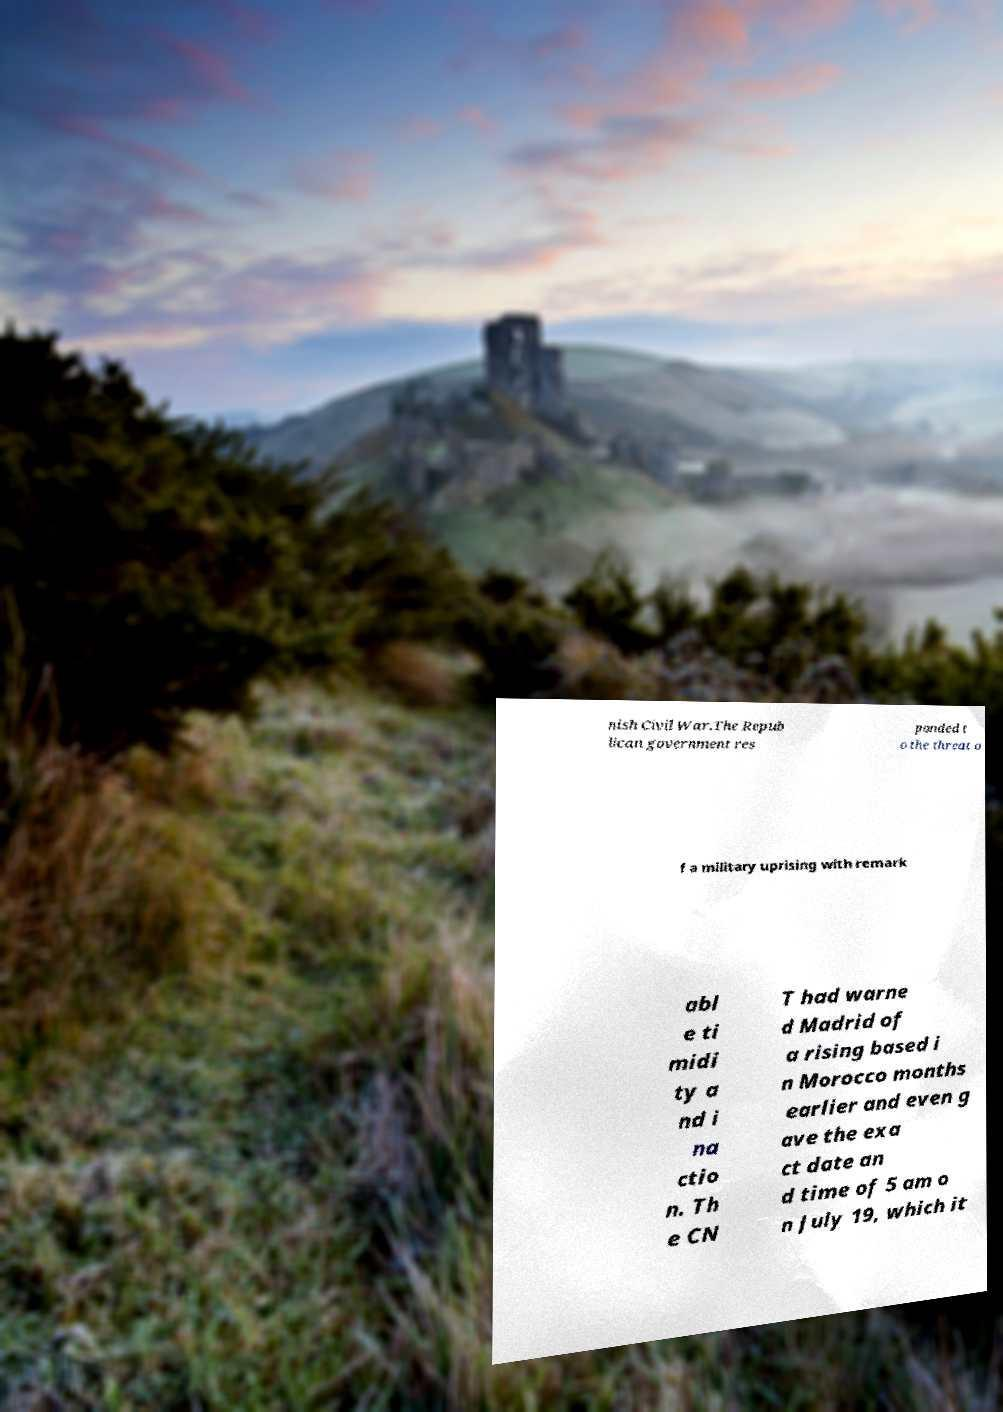Can you accurately transcribe the text from the provided image for me? nish Civil War.The Repub lican government res ponded t o the threat o f a military uprising with remark abl e ti midi ty a nd i na ctio n. Th e CN T had warne d Madrid of a rising based i n Morocco months earlier and even g ave the exa ct date an d time of 5 am o n July 19, which it 